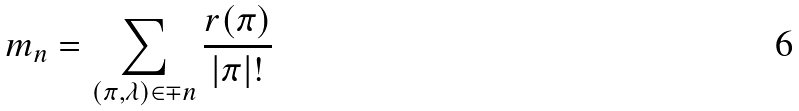Convert formula to latex. <formula><loc_0><loc_0><loc_500><loc_500>m _ { n } = \sum _ { ( \pi , \lambda ) \in \mp n } \frac { r ( \pi ) } { | \pi | ! }</formula> 